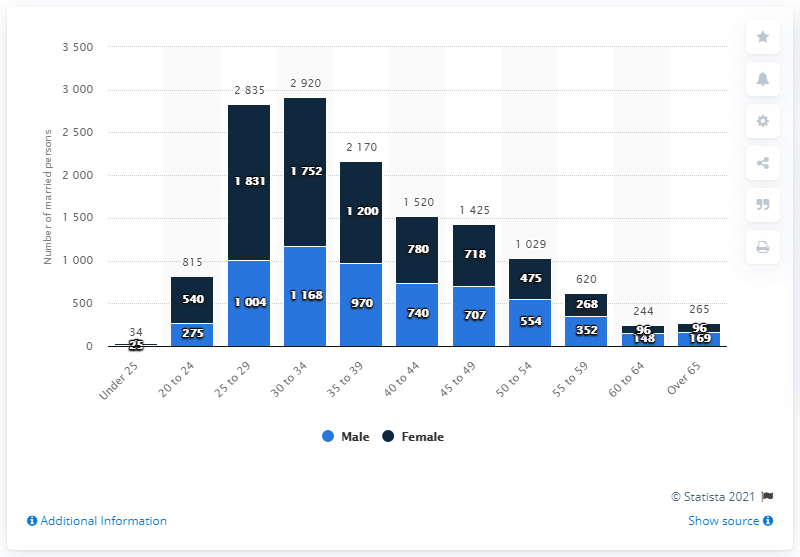Mention a couple of crucial points in this snapshot. There were 1,752 female same-sex marriages in England and Wales in 2017. There were 1,168 male same-sex marriages in England and Wales in 2017. 